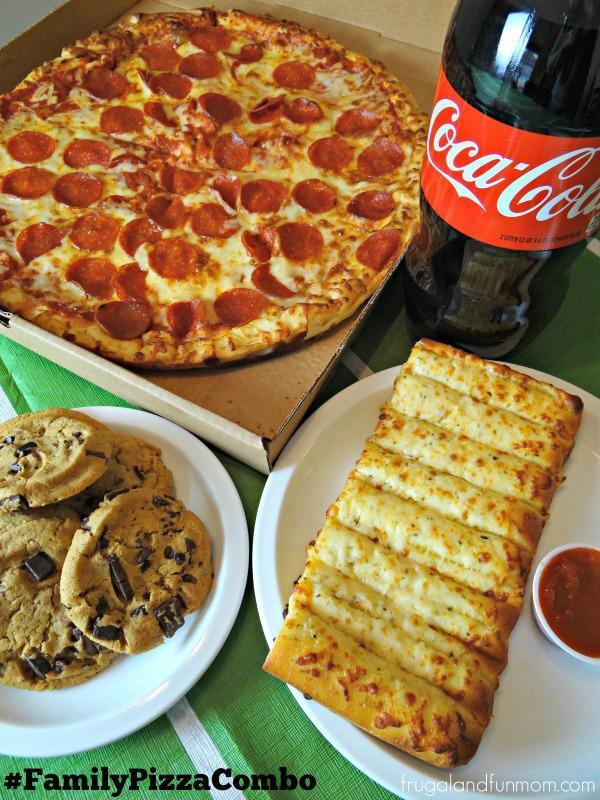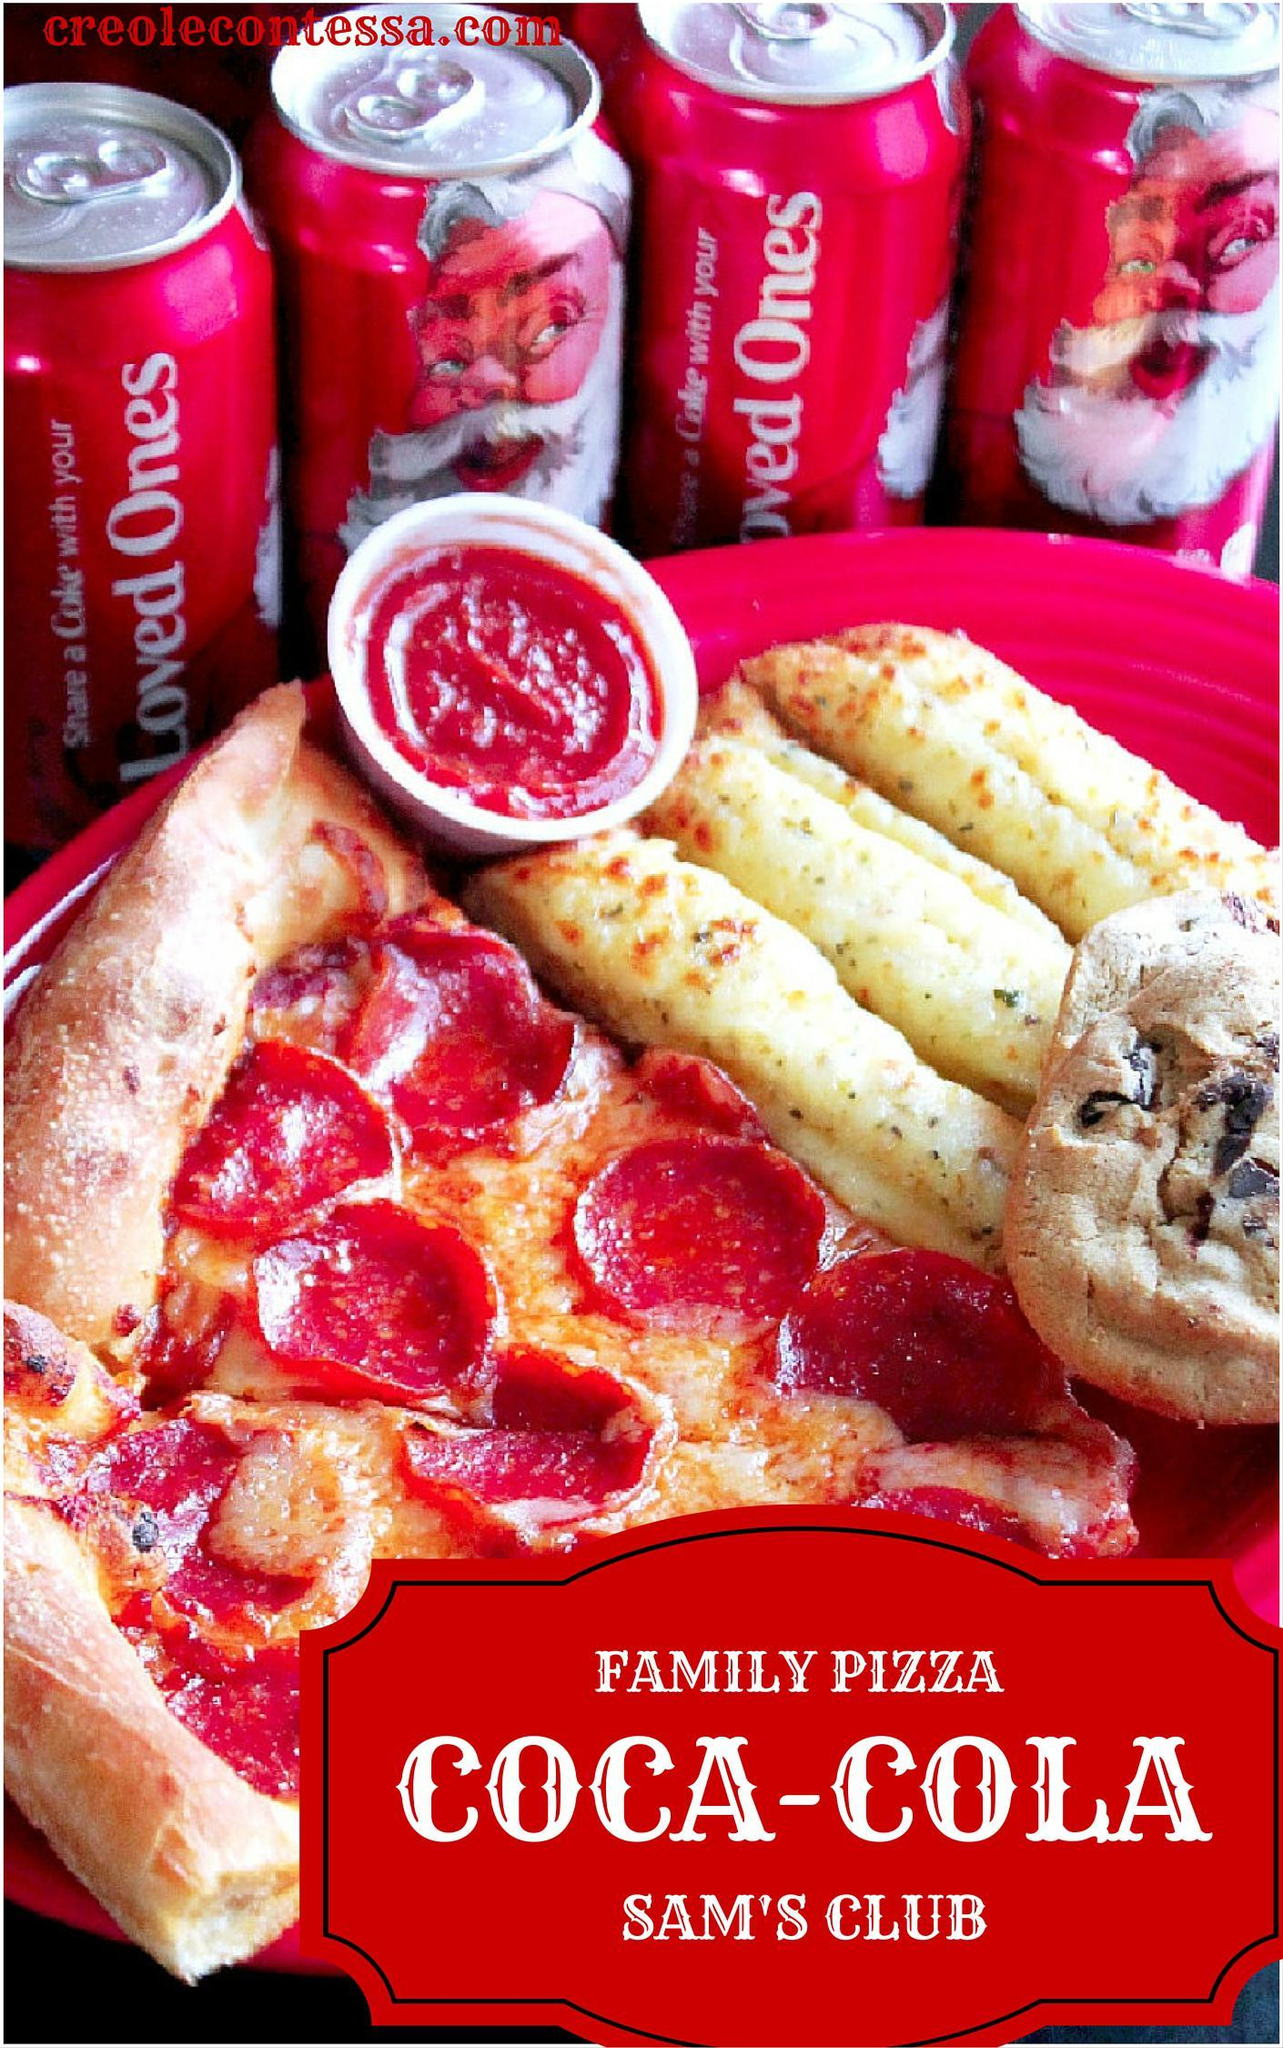The first image is the image on the left, the second image is the image on the right. For the images displayed, is the sentence "The left image includes a pizza in an open box, a plate containing a row of cheesy bread with a container of red sauce next to it, a plate of cookies, and a bottle of cola beside the pizza box." factually correct? Answer yes or no. Yes. The first image is the image on the left, the second image is the image on the right. Examine the images to the left and right. Is the description "The pizza in the image on the right is lying in a cardboard box." accurate? Answer yes or no. No. 